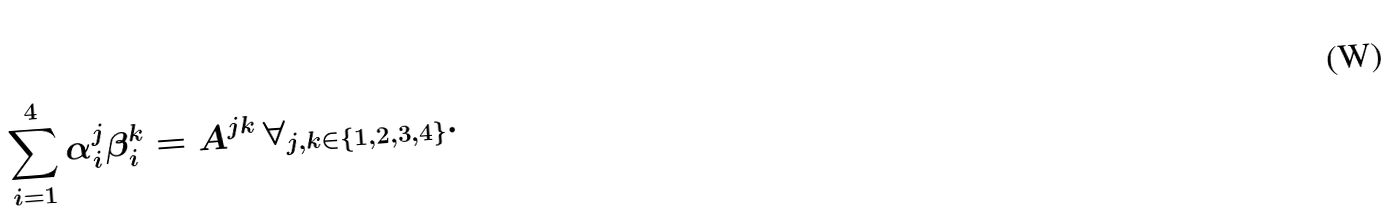<formula> <loc_0><loc_0><loc_500><loc_500>\sum _ { i = 1 } ^ { 4 } \alpha _ { i } ^ { j } \beta _ { i } ^ { k } = A ^ { j k } \, \forall _ { j , k \in \left \{ 1 , 2 , 3 , 4 \right \} } .</formula> 